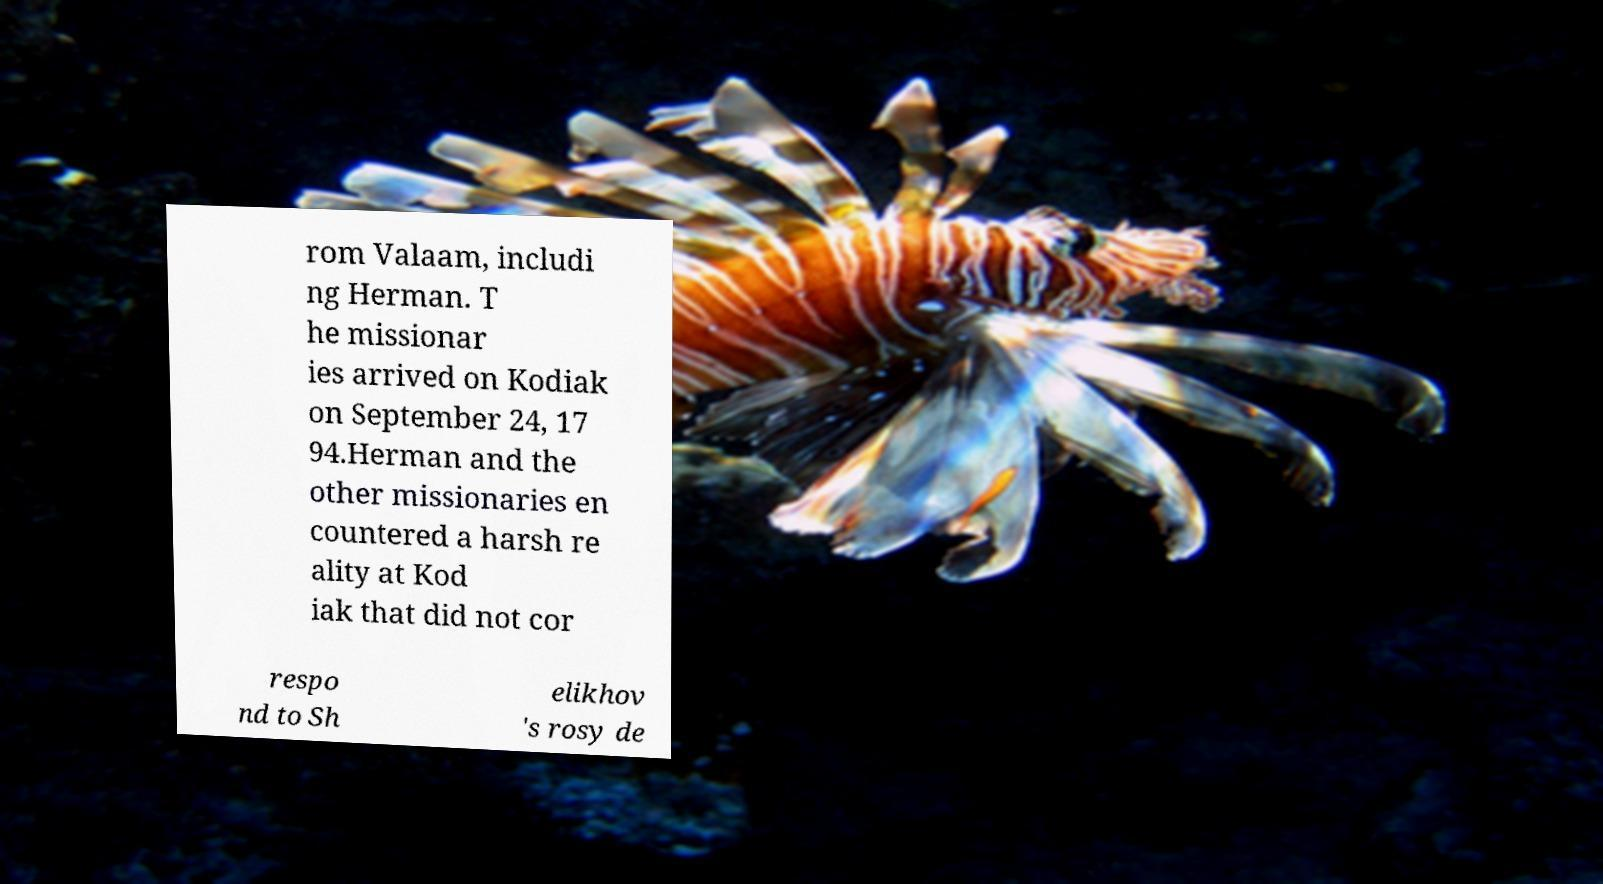I need the written content from this picture converted into text. Can you do that? rom Valaam, includi ng Herman. T he missionar ies arrived on Kodiak on September 24, 17 94.Herman and the other missionaries en countered a harsh re ality at Kod iak that did not cor respo nd to Sh elikhov 's rosy de 